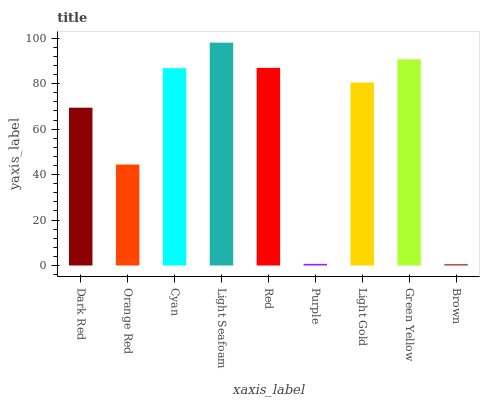Is Brown the minimum?
Answer yes or no. Yes. Is Light Seafoam the maximum?
Answer yes or no. Yes. Is Orange Red the minimum?
Answer yes or no. No. Is Orange Red the maximum?
Answer yes or no. No. Is Dark Red greater than Orange Red?
Answer yes or no. Yes. Is Orange Red less than Dark Red?
Answer yes or no. Yes. Is Orange Red greater than Dark Red?
Answer yes or no. No. Is Dark Red less than Orange Red?
Answer yes or no. No. Is Light Gold the high median?
Answer yes or no. Yes. Is Light Gold the low median?
Answer yes or no. Yes. Is Light Seafoam the high median?
Answer yes or no. No. Is Dark Red the low median?
Answer yes or no. No. 